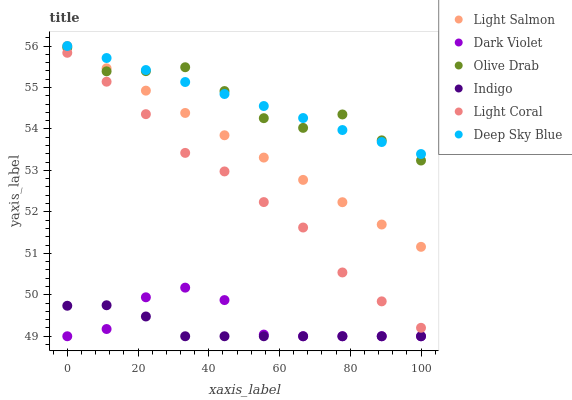Does Indigo have the minimum area under the curve?
Answer yes or no. Yes. Does Deep Sky Blue have the maximum area under the curve?
Answer yes or no. Yes. Does Dark Violet have the minimum area under the curve?
Answer yes or no. No. Does Dark Violet have the maximum area under the curve?
Answer yes or no. No. Is Deep Sky Blue the smoothest?
Answer yes or no. Yes. Is Olive Drab the roughest?
Answer yes or no. Yes. Is Indigo the smoothest?
Answer yes or no. No. Is Indigo the roughest?
Answer yes or no. No. Does Indigo have the lowest value?
Answer yes or no. Yes. Does Light Coral have the lowest value?
Answer yes or no. No. Does Deep Sky Blue have the highest value?
Answer yes or no. Yes. Does Dark Violet have the highest value?
Answer yes or no. No. Is Dark Violet less than Light Coral?
Answer yes or no. Yes. Is Olive Drab greater than Dark Violet?
Answer yes or no. Yes. Does Deep Sky Blue intersect Light Salmon?
Answer yes or no. Yes. Is Deep Sky Blue less than Light Salmon?
Answer yes or no. No. Is Deep Sky Blue greater than Light Salmon?
Answer yes or no. No. Does Dark Violet intersect Light Coral?
Answer yes or no. No. 